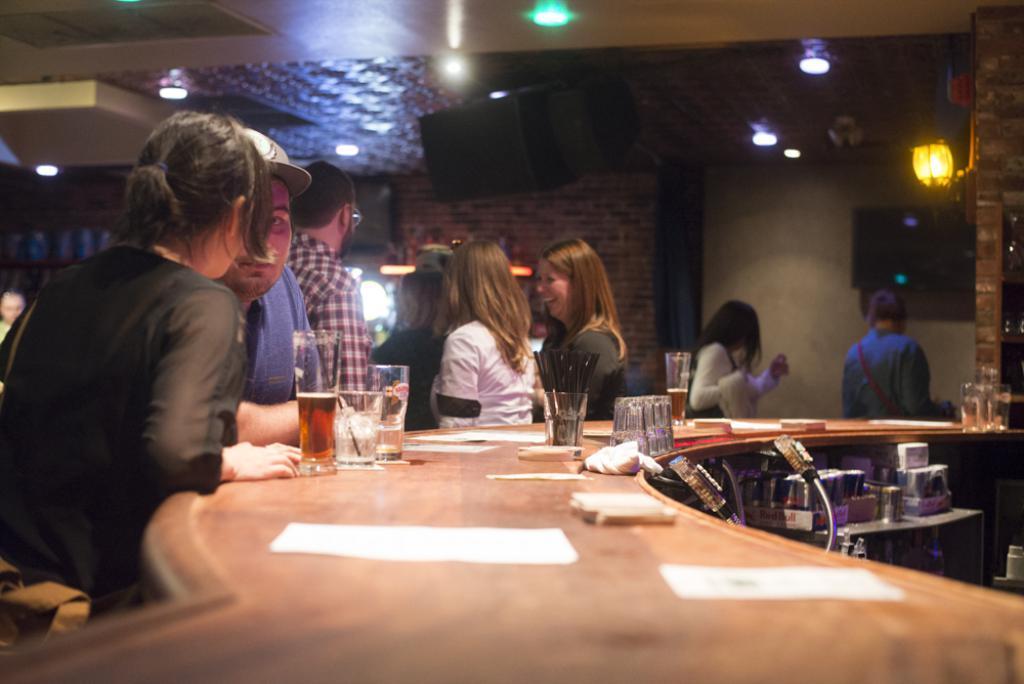How would you summarize this image in a sentence or two? In this image, there is a inside view of a building. There are some people wearing colorful clothes and standing in front of the table. This table contains glasses. There are some light at the top. 